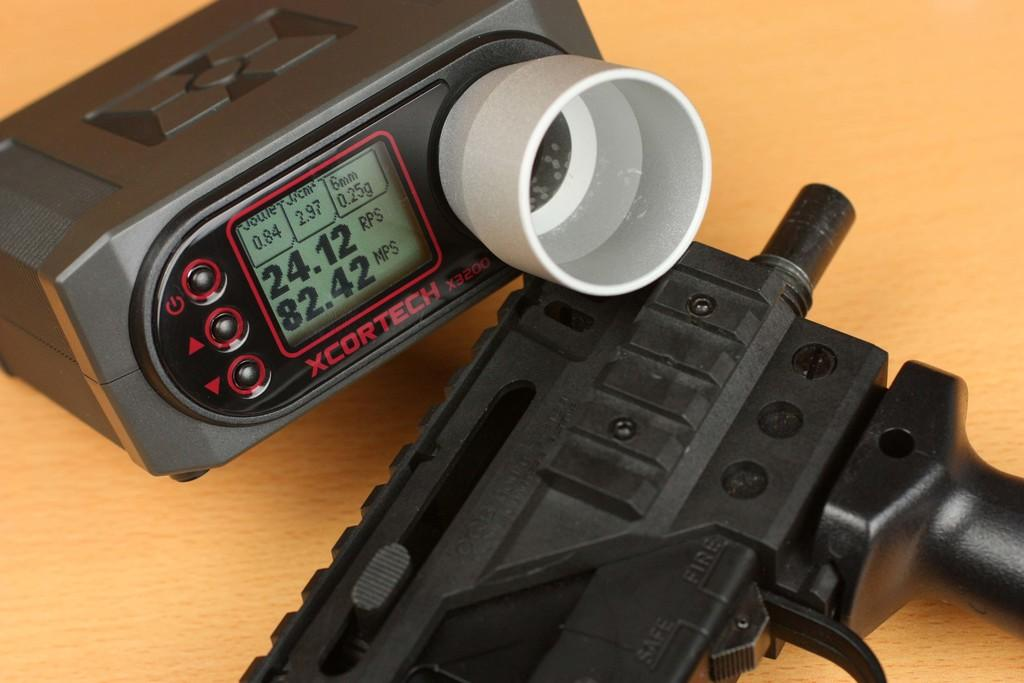What is the color of the surface in the image? The surface in the image is cream-colored. What can be seen on the surface? There is a black-colored object on the surface. What type of gadget is present in the image? There is a white and black-colored gadget with a digital display in the image. How many toys can be seen smiling in the yard in the image? There are no toys or yards present in the image. What type of yard is visible in the image? There is no yard present in the image. 